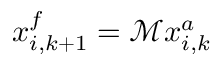Convert formula to latex. <formula><loc_0><loc_0><loc_500><loc_500>x _ { i , k + 1 } ^ { f } = \mathcal { M } x _ { i , k } ^ { a }</formula> 